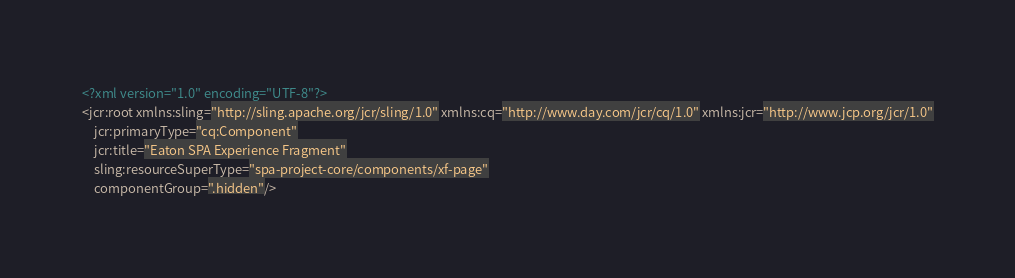<code> <loc_0><loc_0><loc_500><loc_500><_XML_><?xml version="1.0" encoding="UTF-8"?>
<jcr:root xmlns:sling="http://sling.apache.org/jcr/sling/1.0" xmlns:cq="http://www.day.com/jcr/cq/1.0" xmlns:jcr="http://www.jcp.org/jcr/1.0"
    jcr:primaryType="cq:Component"
    jcr:title="Eaton SPA Experience Fragment"
    sling:resourceSuperType="spa-project-core/components/xf-page"
    componentGroup=".hidden"/>
</code> 